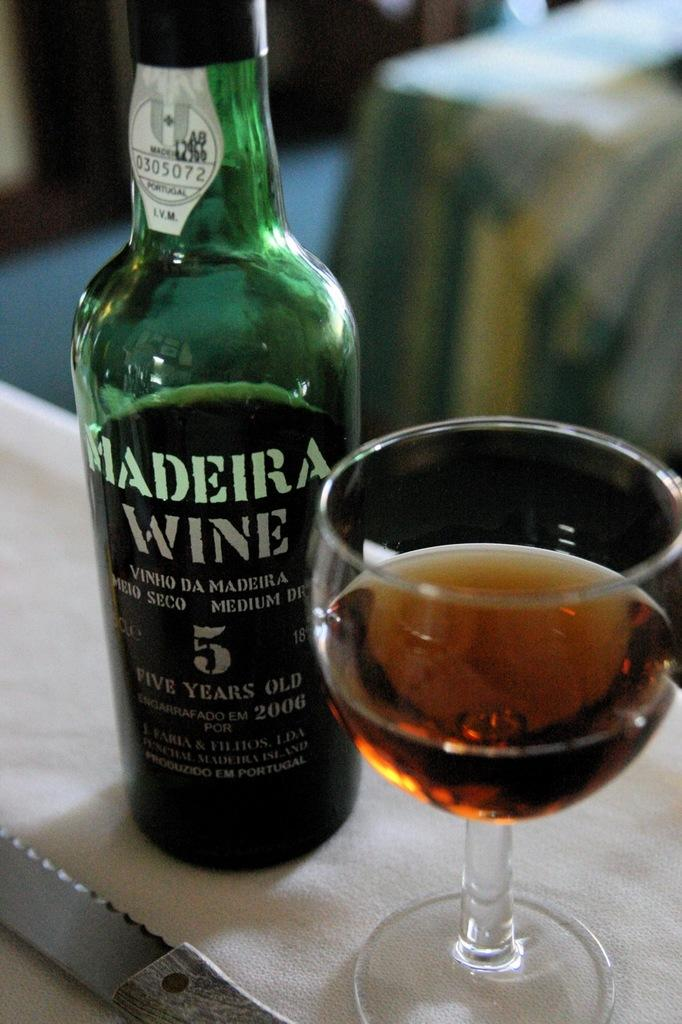<image>
Share a concise interpretation of the image provided. Green Madeira wine bottle next to a glass of wine. 